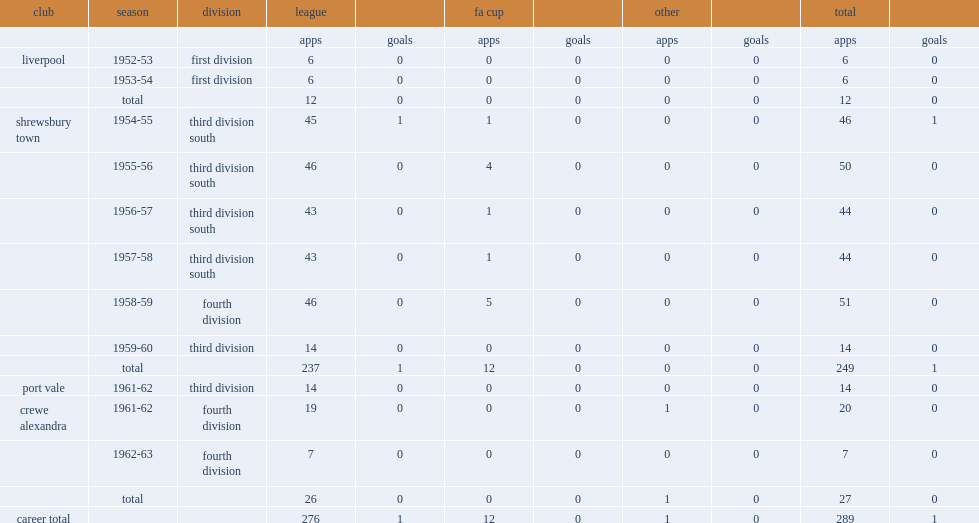Which club did joe maloney sign with in 1958-59? Shrewsbury town. 